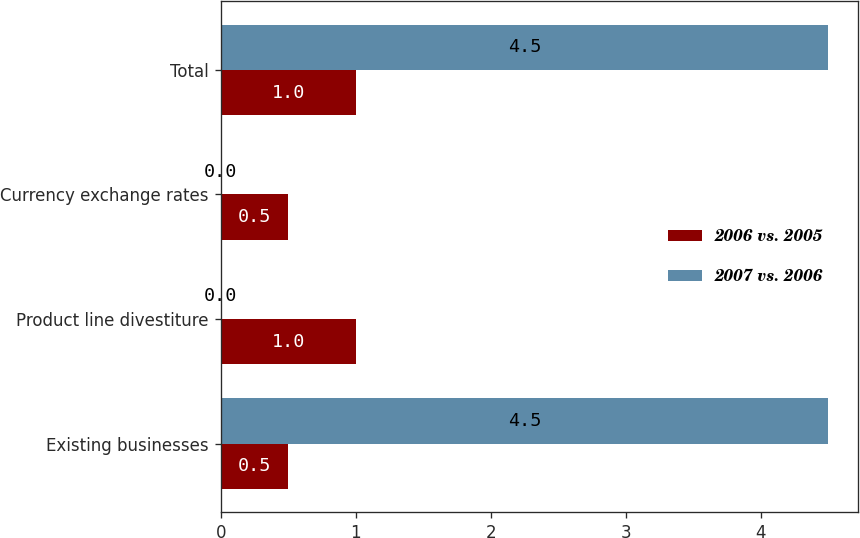Convert chart to OTSL. <chart><loc_0><loc_0><loc_500><loc_500><stacked_bar_chart><ecel><fcel>Existing businesses<fcel>Product line divestiture<fcel>Currency exchange rates<fcel>Total<nl><fcel>2006 vs. 2005<fcel>0.5<fcel>1<fcel>0.5<fcel>1<nl><fcel>2007 vs. 2006<fcel>4.5<fcel>0<fcel>0<fcel>4.5<nl></chart> 